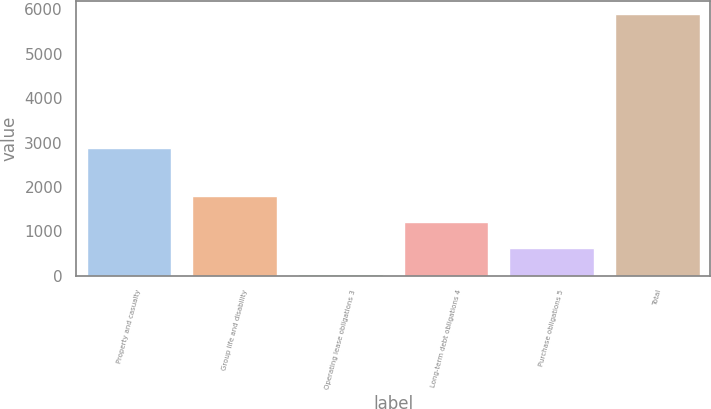Convert chart. <chart><loc_0><loc_0><loc_500><loc_500><bar_chart><fcel>Property and casualty<fcel>Group life and disability<fcel>Operating lease obligations 3<fcel>Long-term debt obligations 4<fcel>Purchase obligations 5<fcel>Total<nl><fcel>2868<fcel>1791.7<fcel>34<fcel>1205.8<fcel>619.9<fcel>5893<nl></chart> 